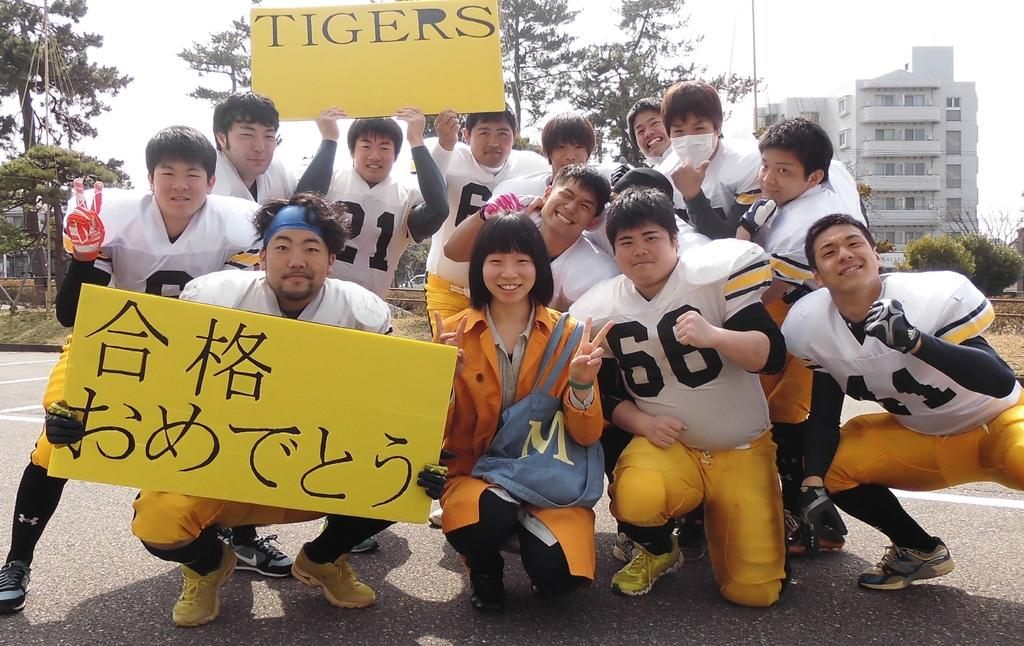What is the main subject of the image? The main subject of the image is a group of persons in the center of the image. Where are the persons located? The persons are on the road. What are the persons holding in the image? The persons are holding boards. What can be seen in the background of the image? There are trees, at least one building, plants, grass, and the sky visible in the background of the image. How many books can be seen on the ground in the image? There are no books visible in the image. Is there a baby crawling on the grass in the background of the image? There is no baby present in the image. 